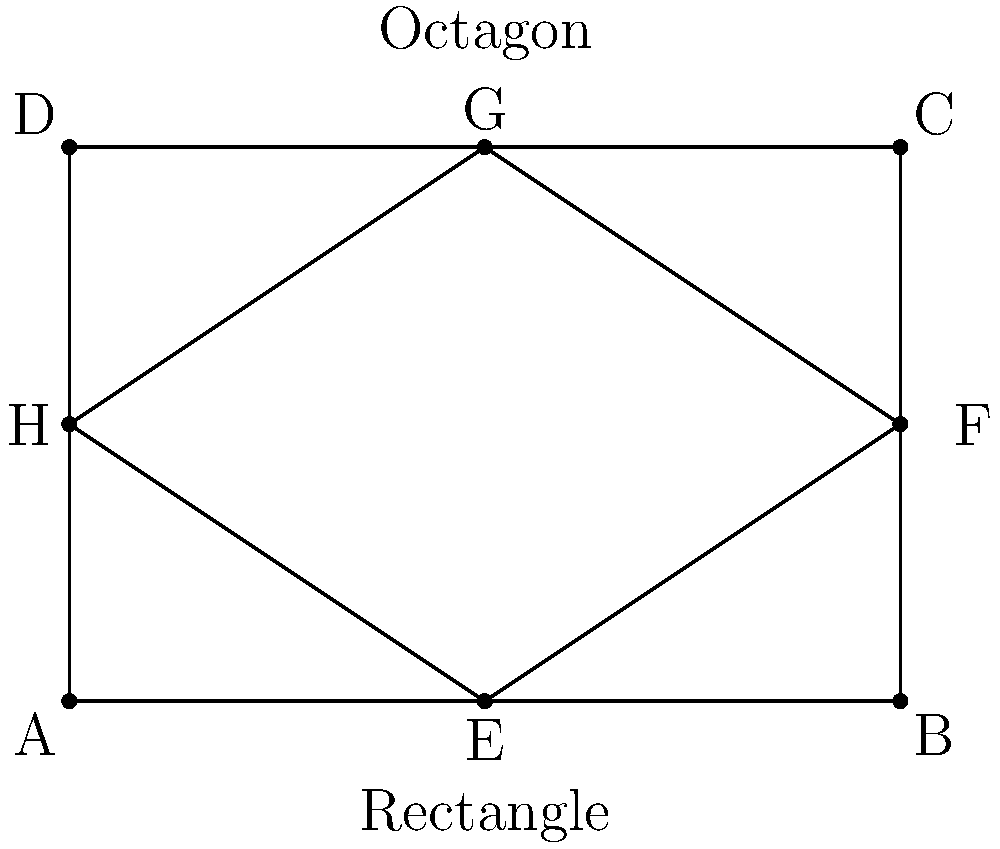As a business owner looking to optimize meeting room layouts, you're considering two shapes for a new room: a rectangle and an octagon. The rectangular room measures 6m by 4m. The octagonal room is formed by cutting equal squares from each corner of the rectangle. If the area of the octagonal room is 75% of the rectangular room's area, what is the side length of each cut-out square? Let's approach this step-by-step:

1) First, calculate the area of the rectangular room:
   $A_{rectangle} = 6m \times 4m = 24m^2$

2) The octagonal room should have 75% of this area:
   $A_{octagon} = 0.75 \times 24m^2 = 18m^2$

3) Let $x$ be the side length of each cut-out square. The area of the octagon can be expressed as:
   $A_{octagon} = A_{rectangle} - 4x^2$

4) Substitute the known values:
   $18 = 24 - 4x^2$

5) Solve for $x^2$:
   $4x^2 = 24 - 18 = 6$
   $x^2 = \frac{6}{4} = 1.5$

6) Take the square root of both sides:
   $x = \sqrt{1.5} = \sqrt{\frac{3}{2}} \approx 1.22m$

Therefore, each cut-out square should have a side length of $\sqrt{\frac{3}{2}}$ meters.
Answer: $\sqrt{\frac{3}{2}}$ meters 